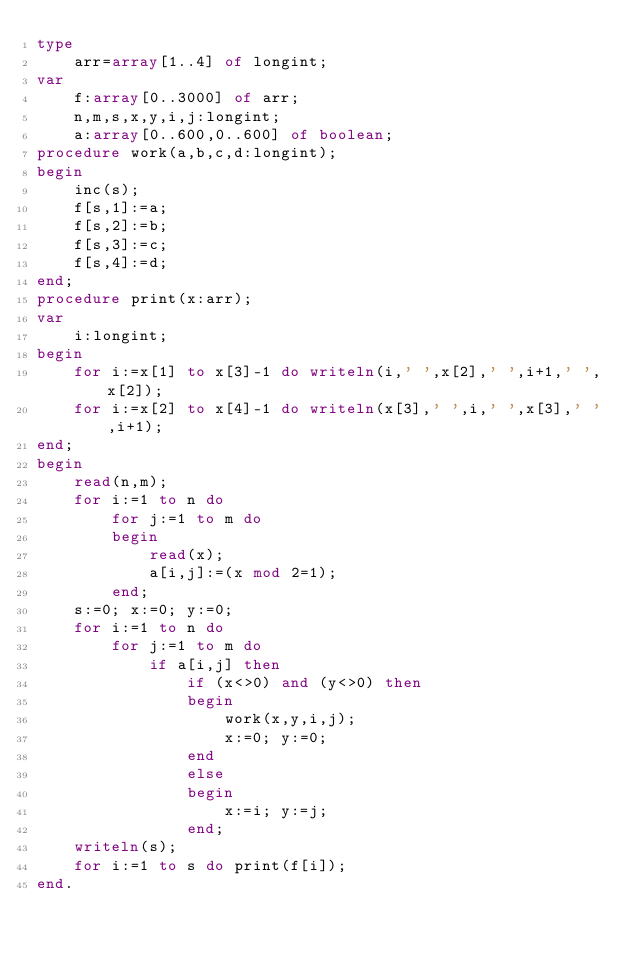Convert code to text. <code><loc_0><loc_0><loc_500><loc_500><_Pascal_>type
	arr=array[1..4] of longint;
var
	f:array[0..3000] of arr;
	n,m,s,x,y,i,j:longint;
	a:array[0..600,0..600] of boolean;
procedure work(a,b,c,d:longint);
begin
	inc(s);
	f[s,1]:=a;
	f[s,2]:=b;
	f[s,3]:=c;
	f[s,4]:=d;
end;
procedure print(x:arr);
var
	i:longint;
begin
	for i:=x[1] to x[3]-1 do writeln(i,' ',x[2],' ',i+1,' ',x[2]);
	for i:=x[2] to x[4]-1 do writeln(x[3],' ',i,' ',x[3],' ',i+1);
end;
begin
	read(n,m);
	for i:=1 to n do
		for j:=1 to m do
		begin	
			read(x);
			a[i,j]:=(x mod 2=1);
		end;
	s:=0; x:=0; y:=0;
	for i:=1 to n do
		for j:=1 to m do
			if a[i,j] then
				if (x<>0) and (y<>0) then
				begin 
					work(x,y,i,j);
					x:=0; y:=0;
				end
				else
				begin
					x:=i; y:=j;
				end;
	writeln(s);
	for i:=1 to s do print(f[i]);
end.</code> 